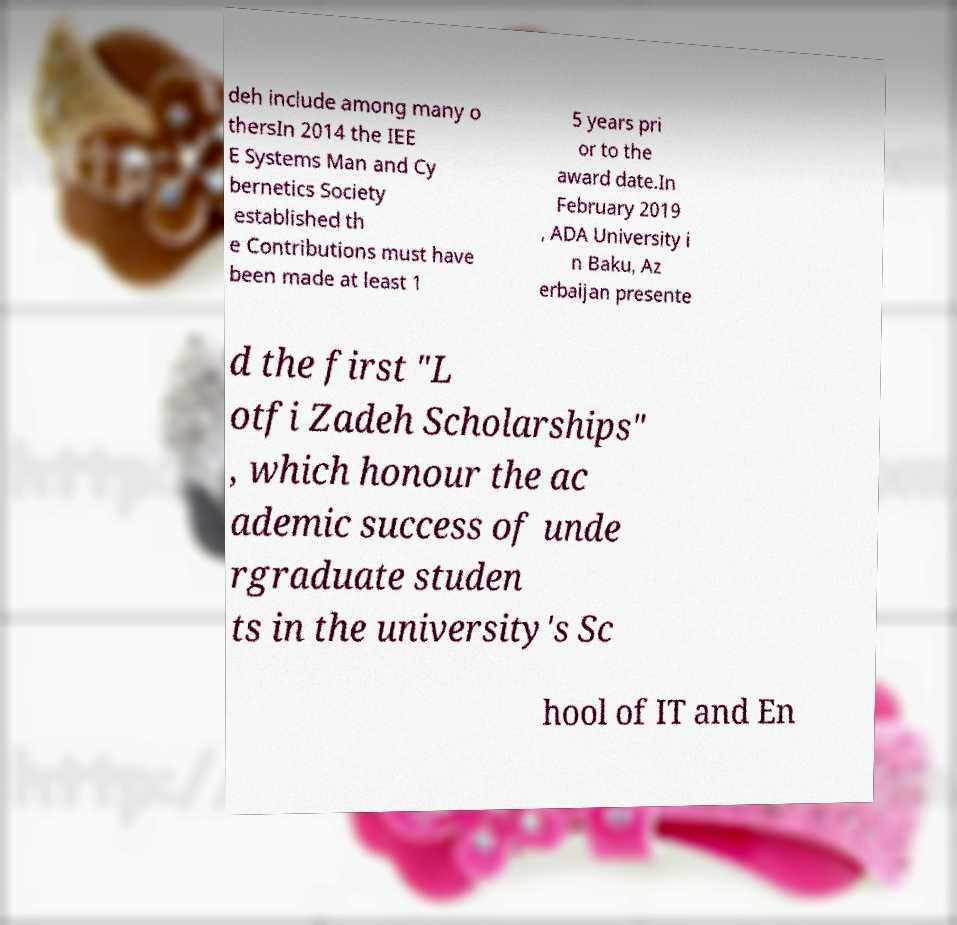Can you accurately transcribe the text from the provided image for me? deh include among many o thersIn 2014 the IEE E Systems Man and Cy bernetics Society established th e Contributions must have been made at least 1 5 years pri or to the award date.In February 2019 , ADA University i n Baku, Az erbaijan presente d the first "L otfi Zadeh Scholarships" , which honour the ac ademic success of unde rgraduate studen ts in the university's Sc hool of IT and En 